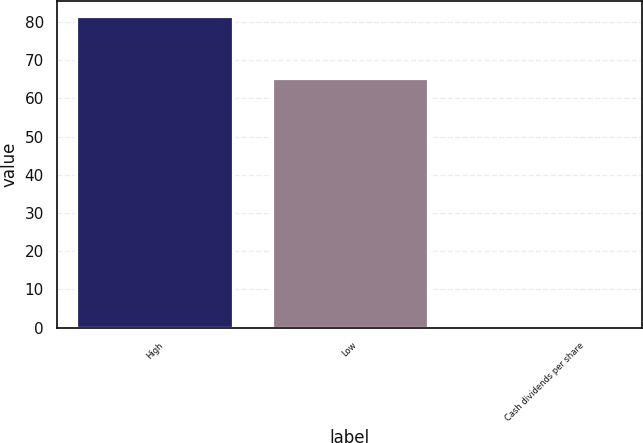Convert chart. <chart><loc_0><loc_0><loc_500><loc_500><bar_chart><fcel>High<fcel>Low<fcel>Cash dividends per share<nl><fcel>81.46<fcel>65.4<fcel>0.11<nl></chart> 